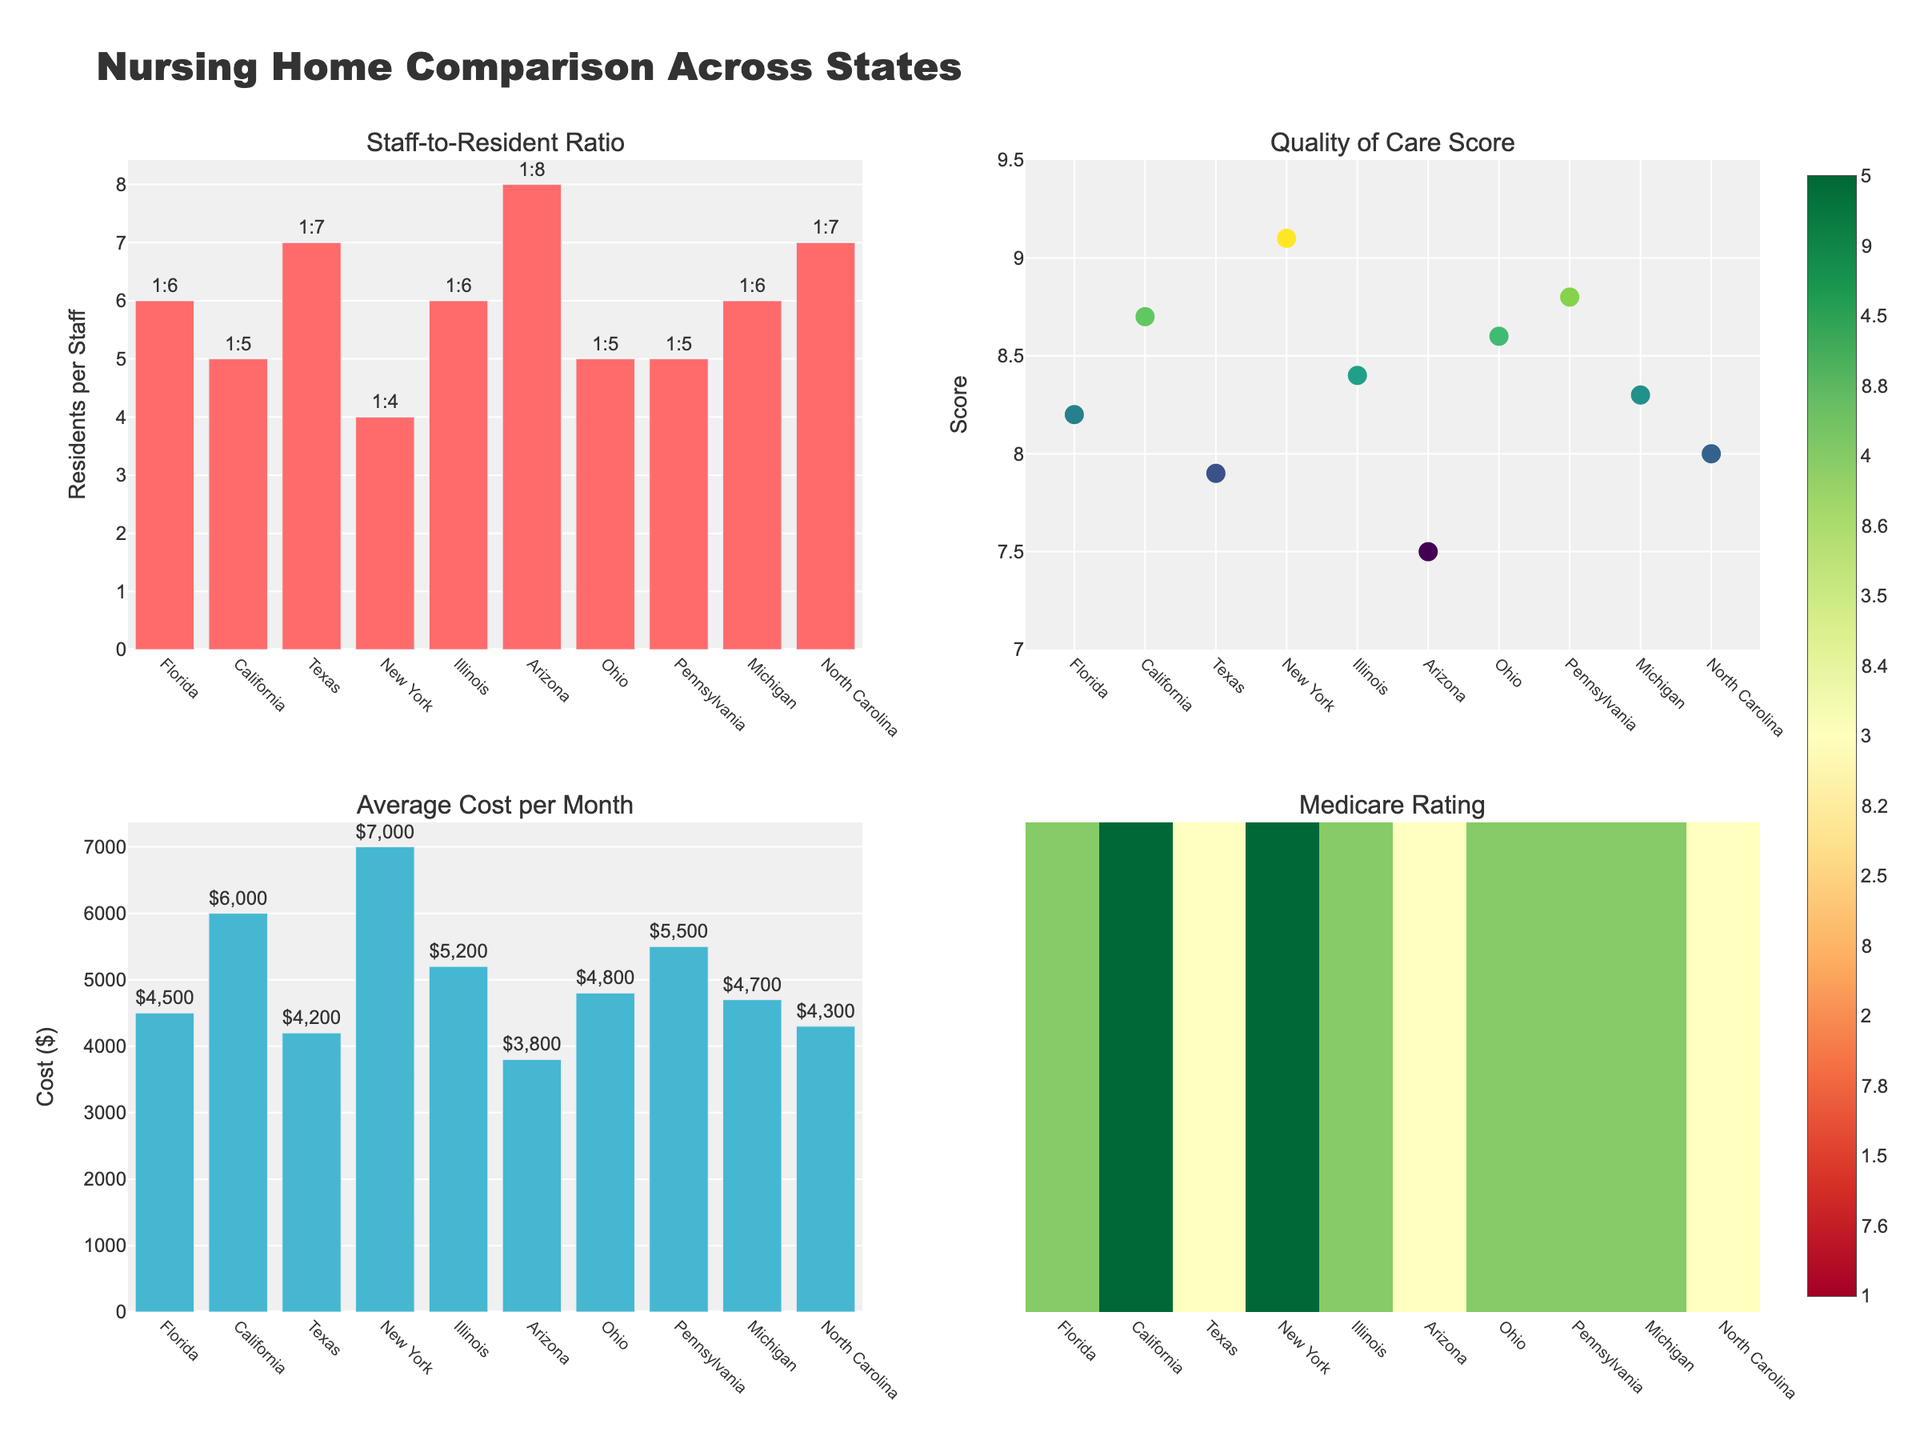Which state has the highest Quality of Care Score? The Quality of Care Score for each state is represented by markers in the top right subplot. New York has the highest score of 9.1.
Answer: New York What is the staff-to-resident ratio in California? The staff-to-resident ratios are shown by bars in the top left subplot, and the text labels indicate the ratio. California’s staff-to-resident ratio is 1:5.
Answer: 1:5 Which state has the lowest average cost per month for nursing homes? The average cost per month is displayed in the bottom left subplot with bars labeling each state’s cost. Arizona has the lowest cost at $3800.
Answer: Arizona Compare the Medicare rating of Florida and Ohio. Which state has a better rating? The Medicare ratings are displayed in the bottom right subplot with a heatmap. Both Florida and Ohio have the same rating of 4.
Answer: Florida and Ohio have equal ratings What is the average Quality of Care Score for the states listed? To find the average, add the Quality of Care Scores of all states and divide by the number of states: (8.2 + 8.7 + 7.9 + 9.1 + 8.4 + 7.5 + 8.6 + 8.8 + 8.3 + 8.0) / 10 = 8.25.
Answer: 8.25 Which state has the highest staff-to-resident ratio, and what is it? The highest staff-to-resident ratio can be found in the top left subplot. Arizona has the highest ratio with 1 staff member per 8 residents.
Answer: Arizona, 1:8 Is there a state that has both a high Quality of Care Score and a low average cost per month? We need to find a state with a Quality of Care Score above 8 and an average cost lower than $5000. Ohio fits with a score of 8.6 and cost of $4800.
Answer: Ohio What is the Medicare rating for Texas, and how does it compare to the overall average Medicare rating? Texas has a Medicare rating of 3. The overall average rating is calculated as follows: (4 + 5 + 3 + 5 + 4 + 3 + 4 + 4 + 4 + 3) / 10 = 3.9. So, Texas has a lower rating than average.
Answer: 3; Lower than average 